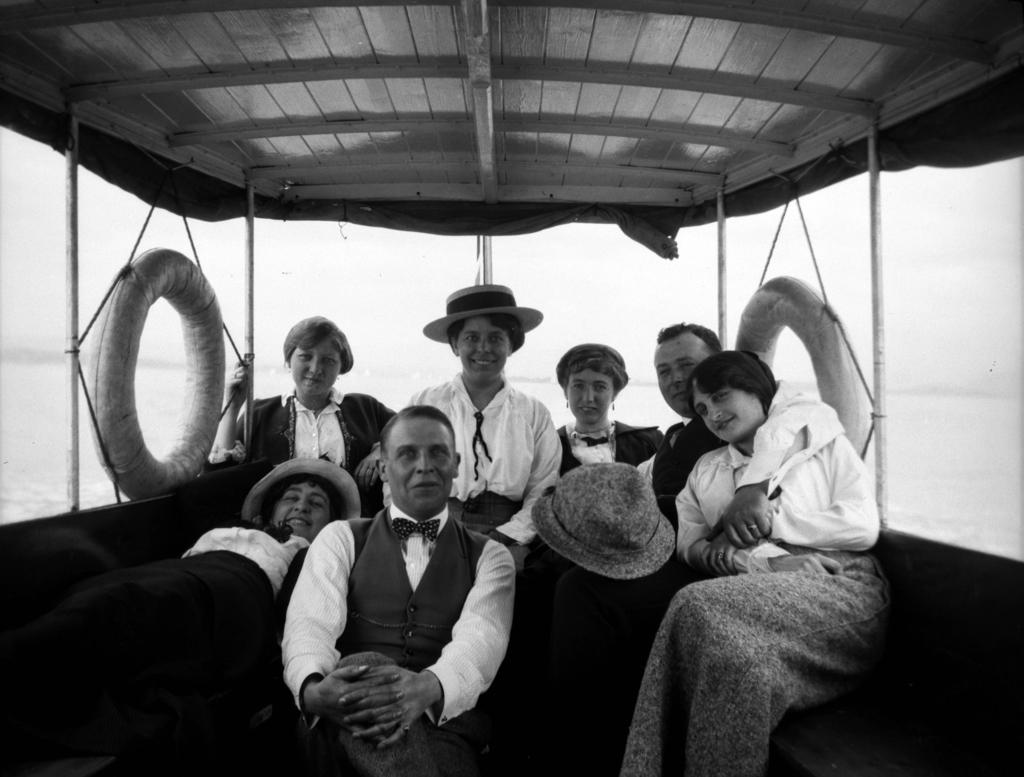What is the color scheme of the image? The image is black and white. What are the people in the image doing? The people are sitting in a boat. Where is the boat located in the image? The boat is floating on water. What else can be seen in the image besides the boat and people? There are tubes visible in the image. How many cows are swimming alongside the boat in the image? There are no cows present in the image; it features people sitting in a boat on water. What type of zebra can be seen grazing on the shore in the image? There is no zebra present in the image; it only shows a boat floating on water with people inside. 